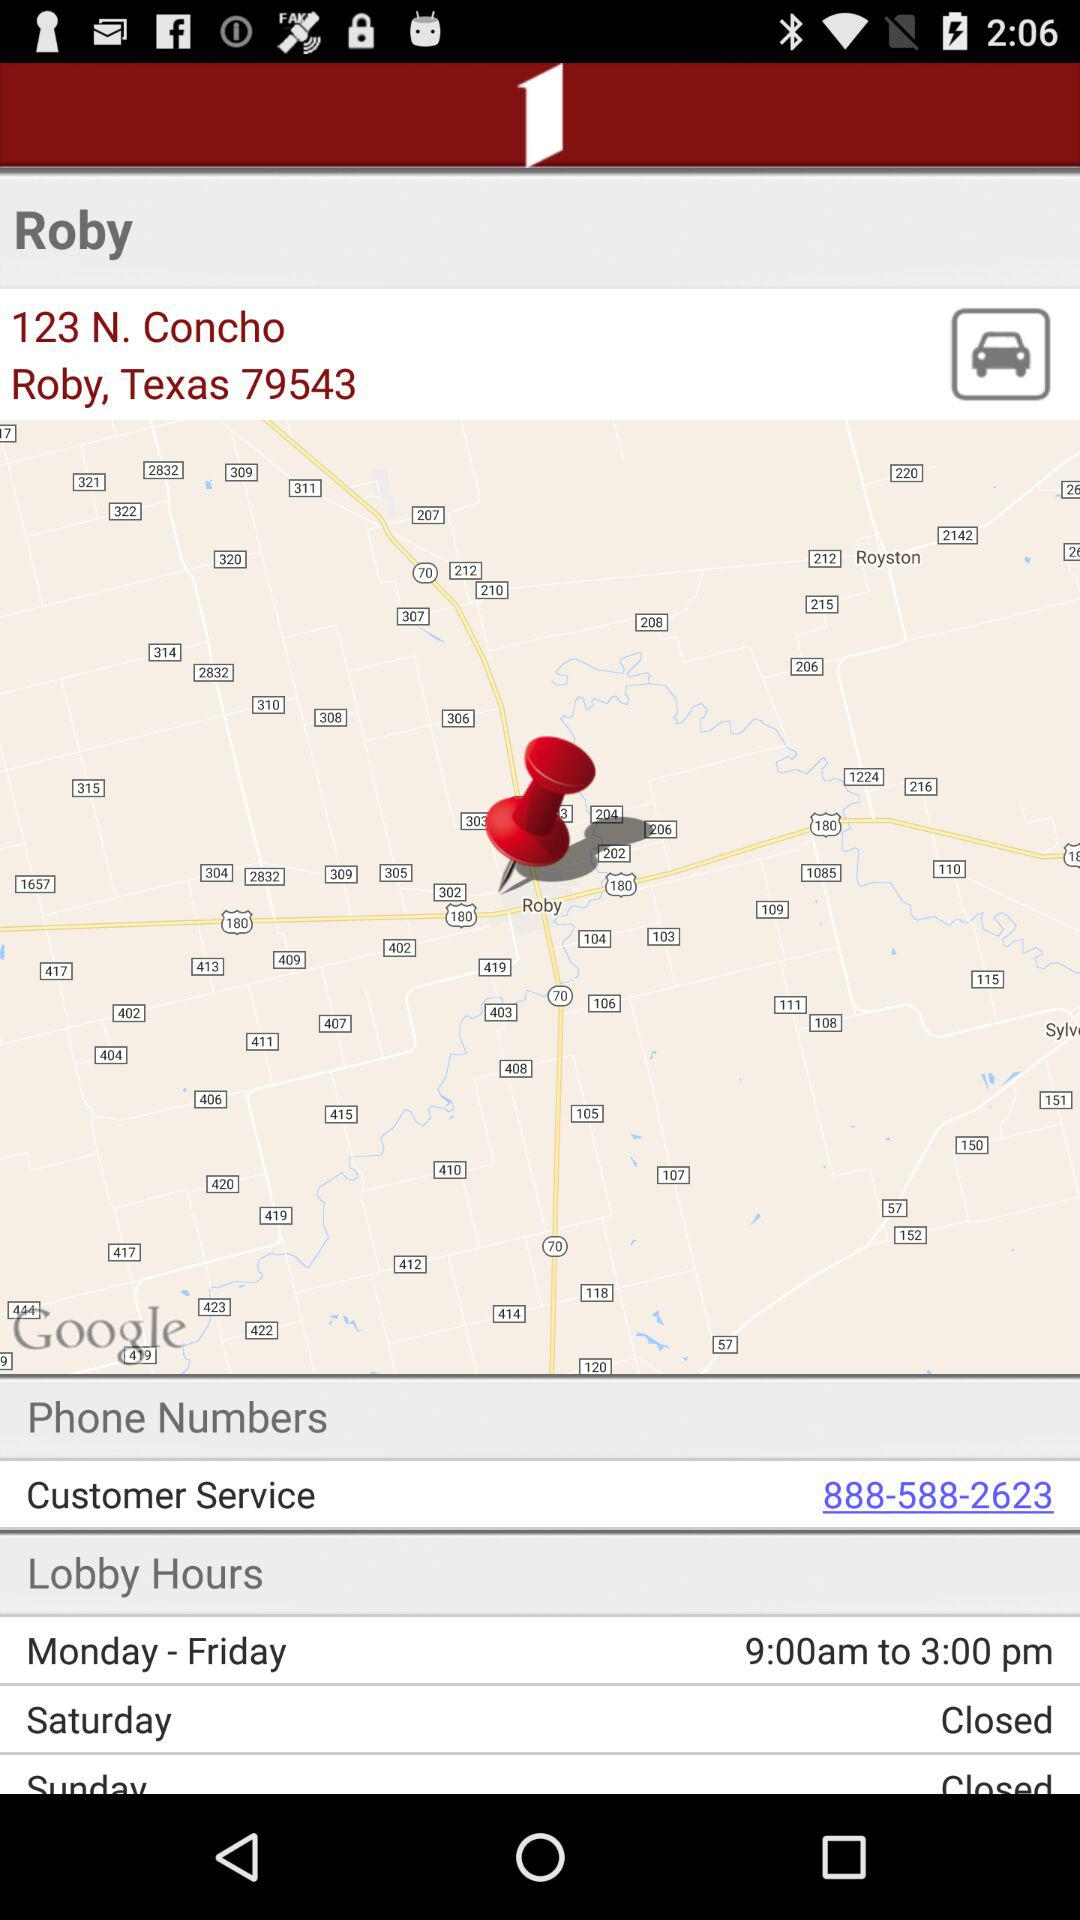What are the lobby hours on Saturday? The lobby is closed on Saturday. 